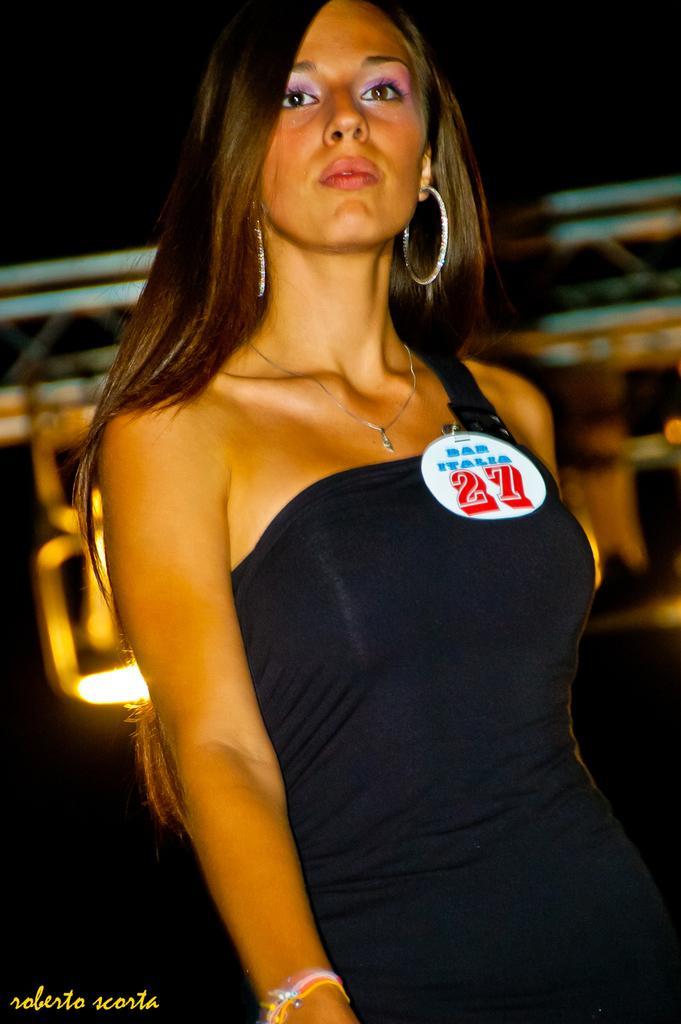In one or two sentences, can you explain what this image depicts? In this picture we can see a woman and there is a dark background. 